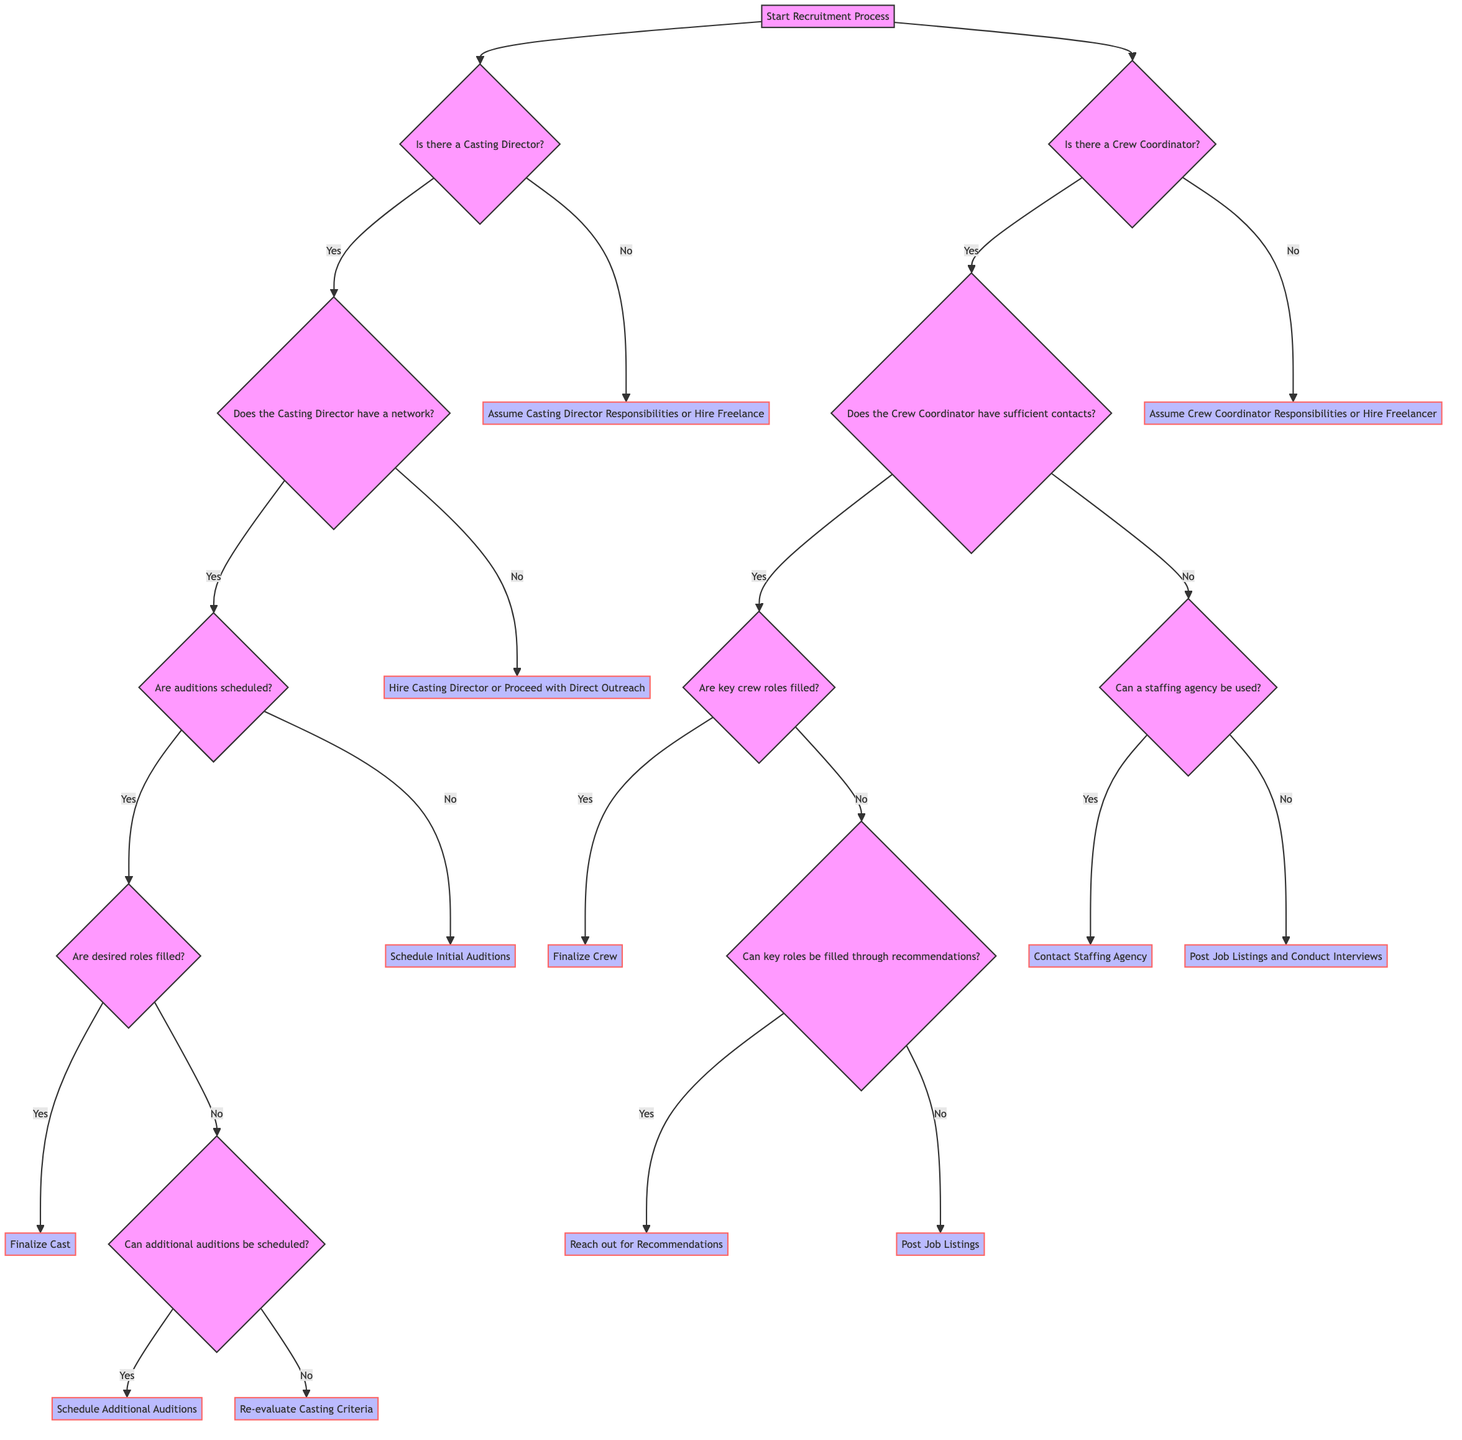Is there a start point in the diagram? The start point in the decision tree is labeled "Start Recruitment Process," where all recruitment activities begin. This establishes the initial node of the diagram.
Answer: Yes How many main branches are there from the start point? From the "Start Recruitment Process," there are two main branches representing the decision nodes for "Is there a Casting Director?" and "Is there a Crew Coordinator?" Therefore, there are two distinct paths to follow in the recruitment process.
Answer: 2 What happens if there is no Casting Director? If there is no Casting Director, the path leads to the decision labeled "Assume Casting Director Responsibilities or Hire Freelance." This indicates the next action to be taken when a casting director is absent.
Answer: Assume Casting Director Responsibilities or Hire Freelancer If a Casting Director is present but has no network, what is the next step? If the Casting Director is present but does not have a network, the diagram specifies the next step as "Hire Casting Director or Proceed with Direct Outreach." This suggests alternative actions when lacking networking resources.
Answer: Hire Casting Director or Proceed with Direct Outreach What happens when key crew roles are not filled? If key crew roles are not filled, the next inquiry is whether key roles can be filled through recommendations. Depending on the response, the outcome will vary: reaching out for recommendations or posting job listings. This step reflects the potential options to resolve unfilled roles.
Answer: Can key roles be filled through recommendations? What is the final outcome if desired roles are filled successfully? If all desired roles are filled successfully, the end point is labeled "Finalize Cast." This indicates the successful completion of the casting process based on the decision flow.
Answer: Finalize Cast What action is taken if additional auditions can be scheduled? If it is determined that additional auditions can be scheduled after checking whether the desired roles are filled, the action taken is "Schedule Additional Auditions." This suggests further efforts towards casting completion.
Answer: Schedule Additional Auditions What is the alternative action if key roles cannot be filled through recommendations? If the options for filling key roles through recommendations are exhausted or unavailable, the alternative action is to "Post Job Listings." This serves as a backup plan for crew recruitment.
Answer: Post Job Listings 